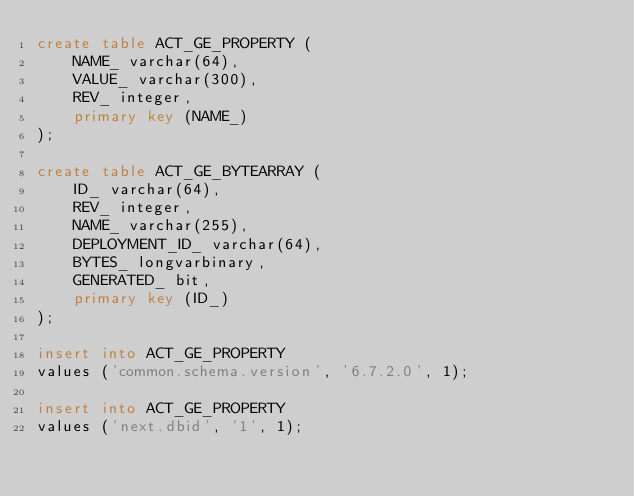Convert code to text. <code><loc_0><loc_0><loc_500><loc_500><_SQL_>create table ACT_GE_PROPERTY (
    NAME_ varchar(64),
    VALUE_ varchar(300),
    REV_ integer,
    primary key (NAME_)
);

create table ACT_GE_BYTEARRAY (
    ID_ varchar(64),
    REV_ integer,
    NAME_ varchar(255),
    DEPLOYMENT_ID_ varchar(64),
    BYTES_ longvarbinary,
    GENERATED_ bit,
    primary key (ID_)
);

insert into ACT_GE_PROPERTY
values ('common.schema.version', '6.7.2.0', 1);

insert into ACT_GE_PROPERTY
values ('next.dbid', '1', 1);
</code> 